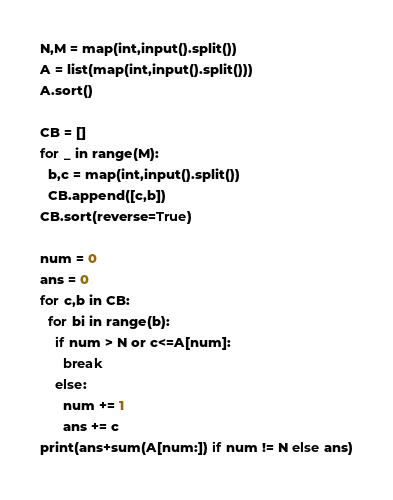Convert code to text. <code><loc_0><loc_0><loc_500><loc_500><_Python_>N,M = map(int,input().split())
A = list(map(int,input().split()))
A.sort()

CB = []
for _ in range(M):
  b,c = map(int,input().split())
  CB.append([c,b])
CB.sort(reverse=True)

num = 0
ans = 0 
for c,b in CB:
  for bi in range(b):
    if num > N or c<=A[num]:
      break
    else:
      num += 1
      ans += c
print(ans+sum(A[num:]) if num != N else ans)</code> 